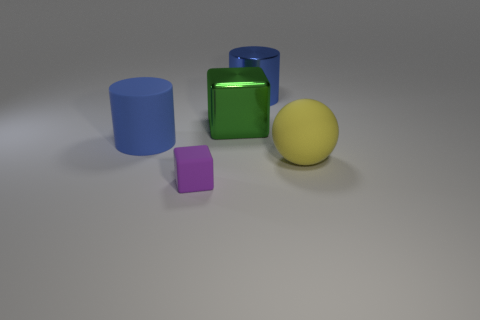Add 5 purple cubes. How many objects exist? 10 Subtract all balls. How many objects are left? 4 Subtract all big blue spheres. Subtract all large rubber things. How many objects are left? 3 Add 2 large rubber things. How many large rubber things are left? 4 Add 2 large blue shiny objects. How many large blue shiny objects exist? 3 Subtract 0 gray balls. How many objects are left? 5 